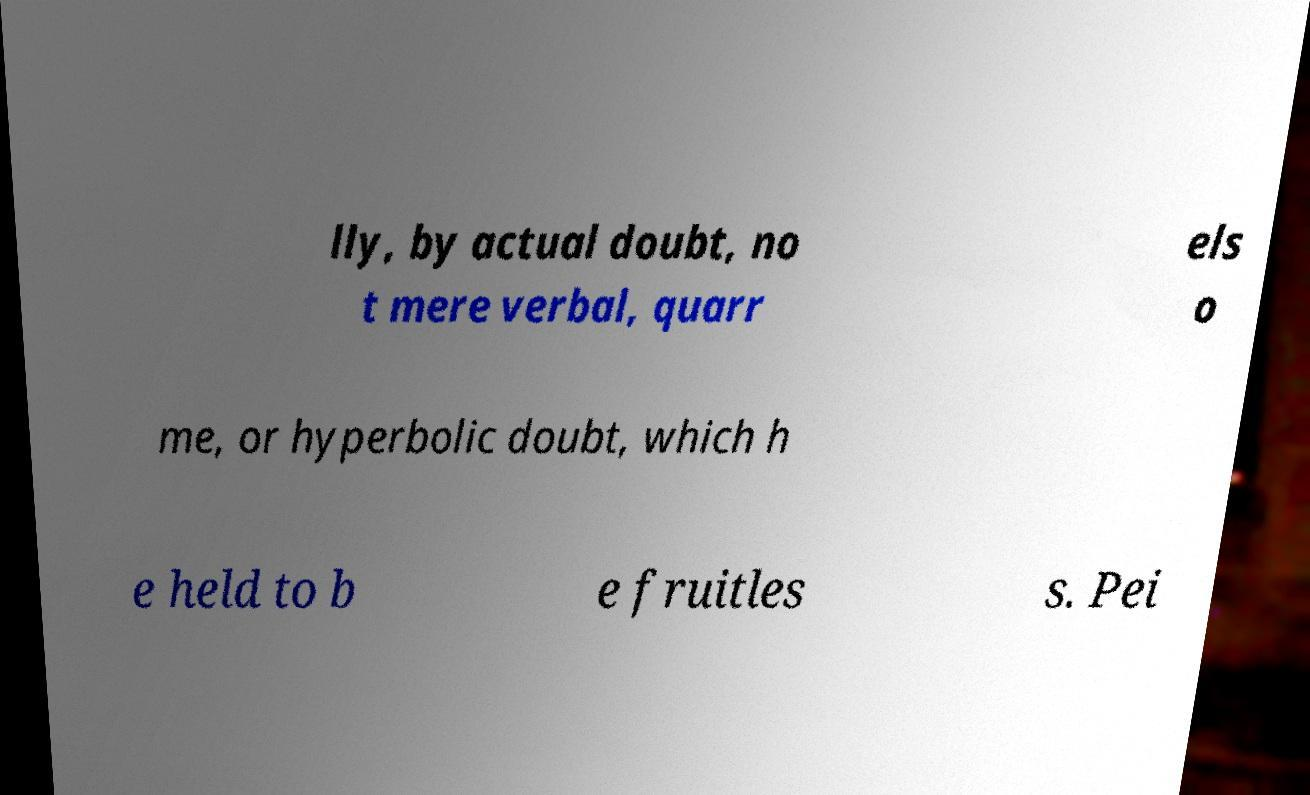Please identify and transcribe the text found in this image. lly, by actual doubt, no t mere verbal, quarr els o me, or hyperbolic doubt, which h e held to b e fruitles s. Pei 